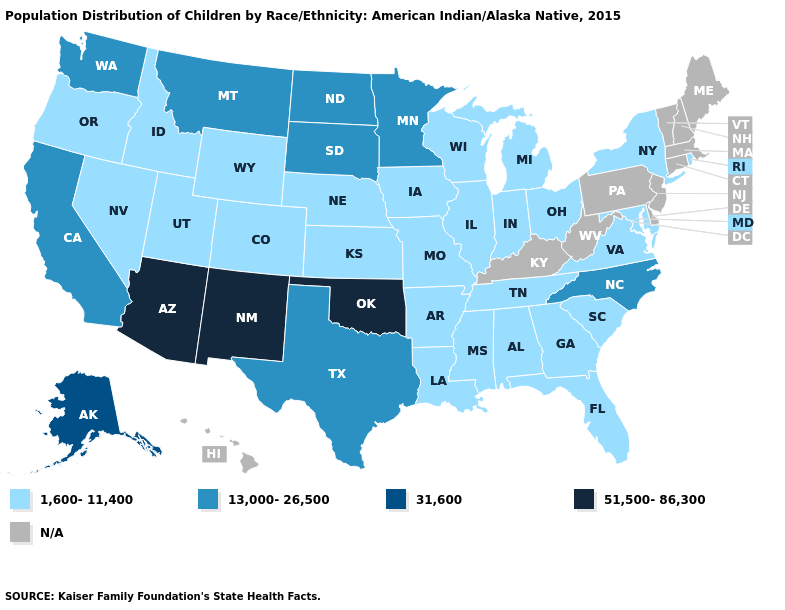What is the value of Maine?
Be succinct. N/A. Which states have the highest value in the USA?
Be succinct. Arizona, New Mexico, Oklahoma. What is the lowest value in the USA?
Write a very short answer. 1,600-11,400. What is the value of Kansas?
Give a very brief answer. 1,600-11,400. What is the value of California?
Give a very brief answer. 13,000-26,500. Among the states that border Kansas , does Oklahoma have the lowest value?
Short answer required. No. What is the lowest value in the MidWest?
Write a very short answer. 1,600-11,400. Name the states that have a value in the range 1,600-11,400?
Give a very brief answer. Alabama, Arkansas, Colorado, Florida, Georgia, Idaho, Illinois, Indiana, Iowa, Kansas, Louisiana, Maryland, Michigan, Mississippi, Missouri, Nebraska, Nevada, New York, Ohio, Oregon, Rhode Island, South Carolina, Tennessee, Utah, Virginia, Wisconsin, Wyoming. Name the states that have a value in the range 31,600?
Answer briefly. Alaska. Is the legend a continuous bar?
Quick response, please. No. What is the value of Montana?
Give a very brief answer. 13,000-26,500. What is the value of Maine?
Concise answer only. N/A. 